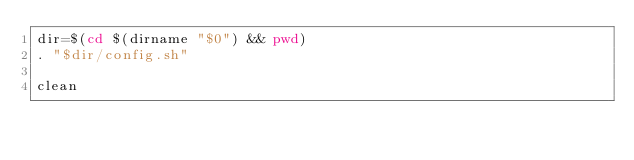<code> <loc_0><loc_0><loc_500><loc_500><_Bash_>dir=$(cd $(dirname "$0") && pwd)
. "$dir/config.sh"

clean
</code> 